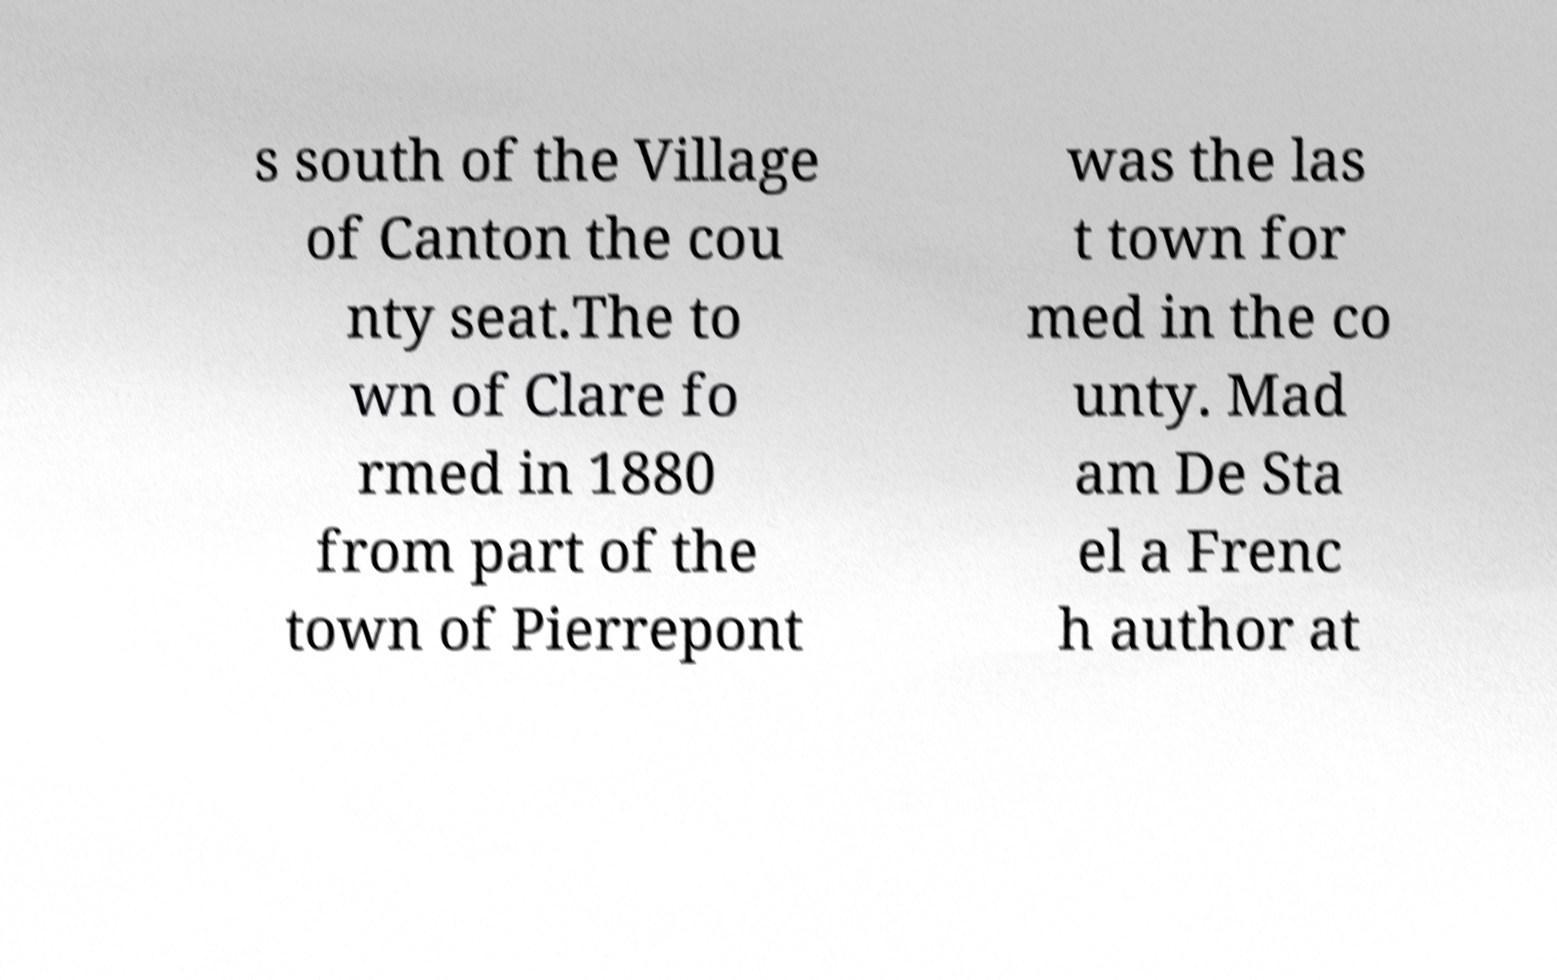There's text embedded in this image that I need extracted. Can you transcribe it verbatim? s south of the Village of Canton the cou nty seat.The to wn of Clare fo rmed in 1880 from part of the town of Pierrepont was the las t town for med in the co unty. Mad am De Sta el a Frenc h author at 